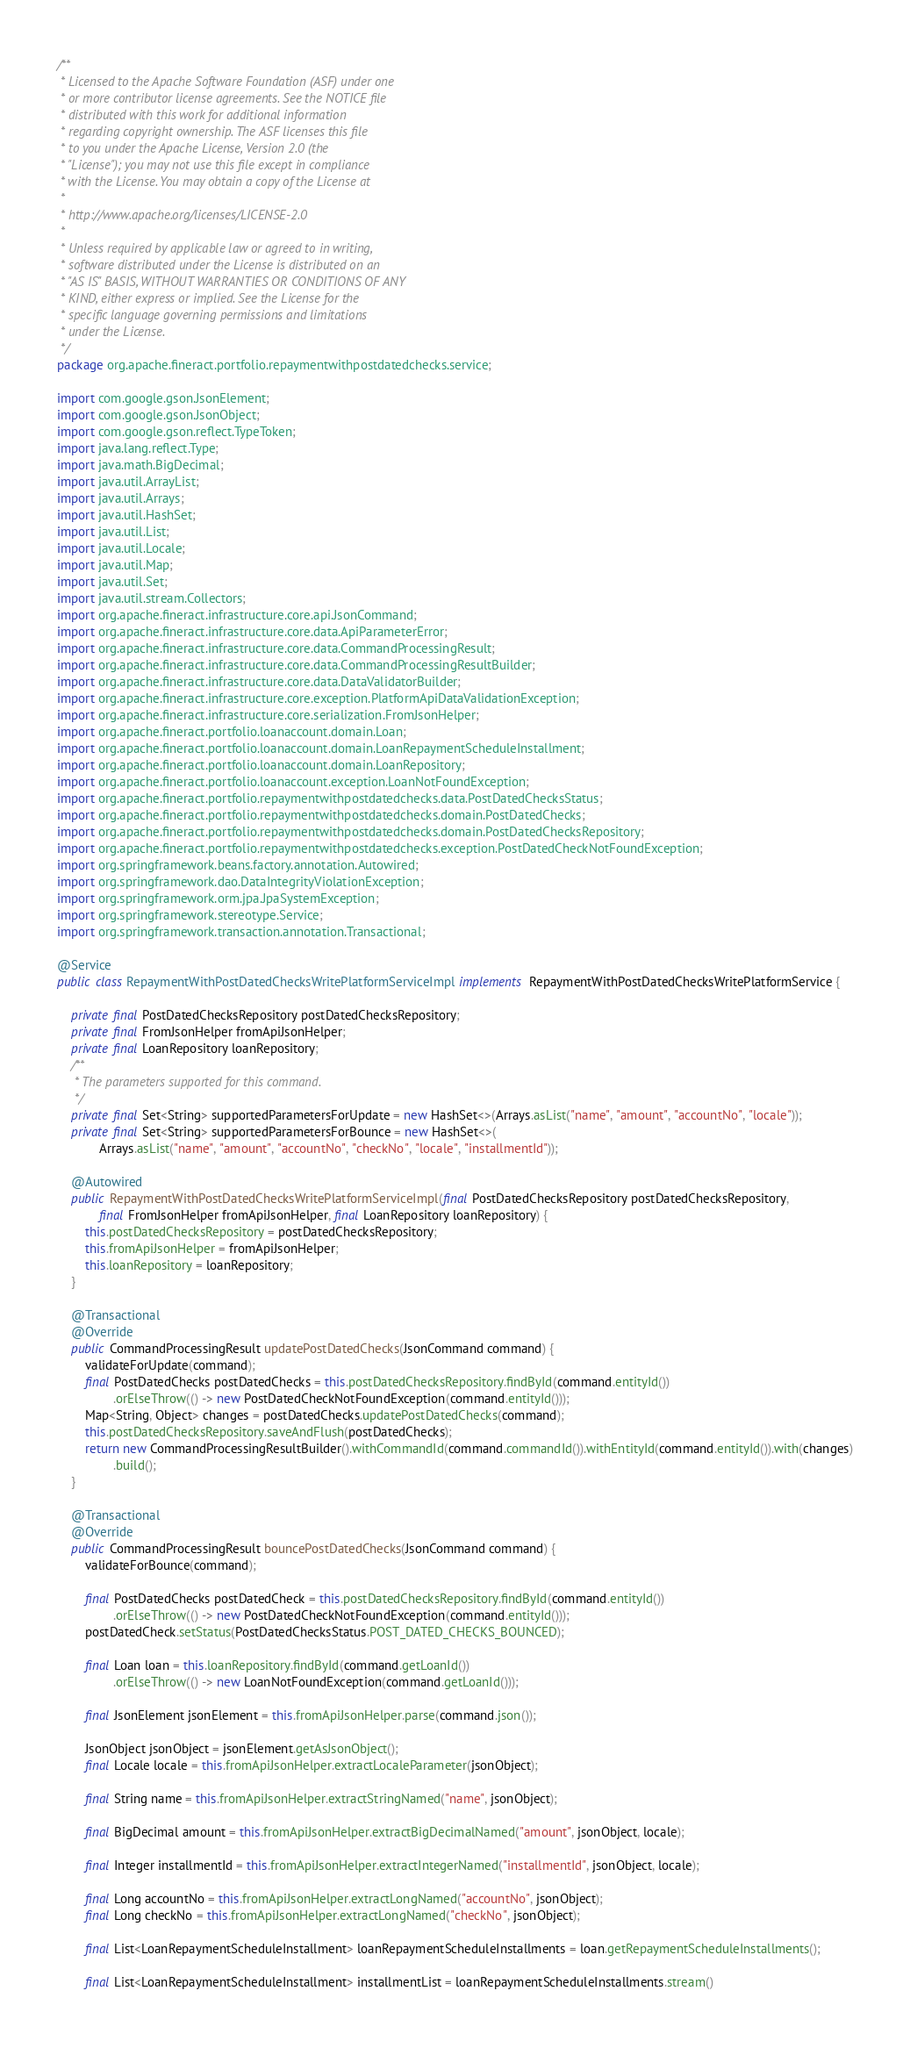Convert code to text. <code><loc_0><loc_0><loc_500><loc_500><_Java_>/**
 * Licensed to the Apache Software Foundation (ASF) under one
 * or more contributor license agreements. See the NOTICE file
 * distributed with this work for additional information
 * regarding copyright ownership. The ASF licenses this file
 * to you under the Apache License, Version 2.0 (the
 * "License"); you may not use this file except in compliance
 * with the License. You may obtain a copy of the License at
 *
 * http://www.apache.org/licenses/LICENSE-2.0
 *
 * Unless required by applicable law or agreed to in writing,
 * software distributed under the License is distributed on an
 * "AS IS" BASIS, WITHOUT WARRANTIES OR CONDITIONS OF ANY
 * KIND, either express or implied. See the License for the
 * specific language governing permissions and limitations
 * under the License.
 */
package org.apache.fineract.portfolio.repaymentwithpostdatedchecks.service;

import com.google.gson.JsonElement;
import com.google.gson.JsonObject;
import com.google.gson.reflect.TypeToken;
import java.lang.reflect.Type;
import java.math.BigDecimal;
import java.util.ArrayList;
import java.util.Arrays;
import java.util.HashSet;
import java.util.List;
import java.util.Locale;
import java.util.Map;
import java.util.Set;
import java.util.stream.Collectors;
import org.apache.fineract.infrastructure.core.api.JsonCommand;
import org.apache.fineract.infrastructure.core.data.ApiParameterError;
import org.apache.fineract.infrastructure.core.data.CommandProcessingResult;
import org.apache.fineract.infrastructure.core.data.CommandProcessingResultBuilder;
import org.apache.fineract.infrastructure.core.data.DataValidatorBuilder;
import org.apache.fineract.infrastructure.core.exception.PlatformApiDataValidationException;
import org.apache.fineract.infrastructure.core.serialization.FromJsonHelper;
import org.apache.fineract.portfolio.loanaccount.domain.Loan;
import org.apache.fineract.portfolio.loanaccount.domain.LoanRepaymentScheduleInstallment;
import org.apache.fineract.portfolio.loanaccount.domain.LoanRepository;
import org.apache.fineract.portfolio.loanaccount.exception.LoanNotFoundException;
import org.apache.fineract.portfolio.repaymentwithpostdatedchecks.data.PostDatedChecksStatus;
import org.apache.fineract.portfolio.repaymentwithpostdatedchecks.domain.PostDatedChecks;
import org.apache.fineract.portfolio.repaymentwithpostdatedchecks.domain.PostDatedChecksRepository;
import org.apache.fineract.portfolio.repaymentwithpostdatedchecks.exception.PostDatedCheckNotFoundException;
import org.springframework.beans.factory.annotation.Autowired;
import org.springframework.dao.DataIntegrityViolationException;
import org.springframework.orm.jpa.JpaSystemException;
import org.springframework.stereotype.Service;
import org.springframework.transaction.annotation.Transactional;

@Service
public class RepaymentWithPostDatedChecksWritePlatformServiceImpl implements RepaymentWithPostDatedChecksWritePlatformService {

    private final PostDatedChecksRepository postDatedChecksRepository;
    private final FromJsonHelper fromApiJsonHelper;
    private final LoanRepository loanRepository;
    /**
     * The parameters supported for this command.
     */
    private final Set<String> supportedParametersForUpdate = new HashSet<>(Arrays.asList("name", "amount", "accountNo", "locale"));
    private final Set<String> supportedParametersForBounce = new HashSet<>(
            Arrays.asList("name", "amount", "accountNo", "checkNo", "locale", "installmentId"));

    @Autowired
    public RepaymentWithPostDatedChecksWritePlatformServiceImpl(final PostDatedChecksRepository postDatedChecksRepository,
            final FromJsonHelper fromApiJsonHelper, final LoanRepository loanRepository) {
        this.postDatedChecksRepository = postDatedChecksRepository;
        this.fromApiJsonHelper = fromApiJsonHelper;
        this.loanRepository = loanRepository;
    }

    @Transactional
    @Override
    public CommandProcessingResult updatePostDatedChecks(JsonCommand command) {
        validateForUpdate(command);
        final PostDatedChecks postDatedChecks = this.postDatedChecksRepository.findById(command.entityId())
                .orElseThrow(() -> new PostDatedCheckNotFoundException(command.entityId()));
        Map<String, Object> changes = postDatedChecks.updatePostDatedChecks(command);
        this.postDatedChecksRepository.saveAndFlush(postDatedChecks);
        return new CommandProcessingResultBuilder().withCommandId(command.commandId()).withEntityId(command.entityId()).with(changes)
                .build();
    }

    @Transactional
    @Override
    public CommandProcessingResult bouncePostDatedChecks(JsonCommand command) {
        validateForBounce(command);

        final PostDatedChecks postDatedCheck = this.postDatedChecksRepository.findById(command.entityId())
                .orElseThrow(() -> new PostDatedCheckNotFoundException(command.entityId()));
        postDatedCheck.setStatus(PostDatedChecksStatus.POST_DATED_CHECKS_BOUNCED);

        final Loan loan = this.loanRepository.findById(command.getLoanId())
                .orElseThrow(() -> new LoanNotFoundException(command.getLoanId()));

        final JsonElement jsonElement = this.fromApiJsonHelper.parse(command.json());

        JsonObject jsonObject = jsonElement.getAsJsonObject();
        final Locale locale = this.fromApiJsonHelper.extractLocaleParameter(jsonObject);

        final String name = this.fromApiJsonHelper.extractStringNamed("name", jsonObject);

        final BigDecimal amount = this.fromApiJsonHelper.extractBigDecimalNamed("amount", jsonObject, locale);

        final Integer installmentId = this.fromApiJsonHelper.extractIntegerNamed("installmentId", jsonObject, locale);

        final Long accountNo = this.fromApiJsonHelper.extractLongNamed("accountNo", jsonObject);
        final Long checkNo = this.fromApiJsonHelper.extractLongNamed("checkNo", jsonObject);

        final List<LoanRepaymentScheduleInstallment> loanRepaymentScheduleInstallments = loan.getRepaymentScheduleInstallments();

        final List<LoanRepaymentScheduleInstallment> installmentList = loanRepaymentScheduleInstallments.stream()</code> 